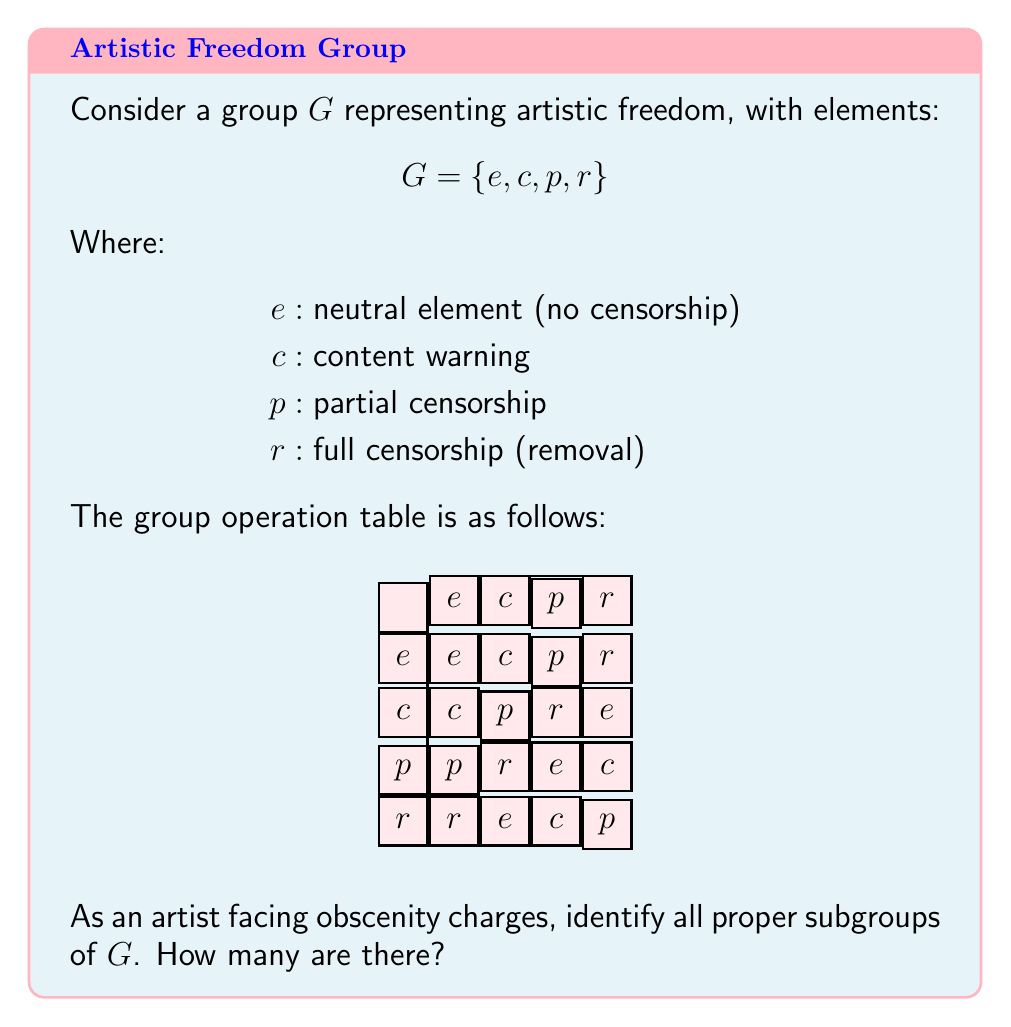Can you solve this math problem? To find the subgroups of $G$, we follow these steps:

1) First, note that $\{e\}$ is always a subgroup (the trivial subgroup).

2) Check for cyclic subgroups generated by each non-identity element:

   For $c$: $\langle c \rangle = \{e, c\}$ (order 2)
   For $p$: $\langle p \rangle = \{e, p\}$ (order 2)
   For $r$: $\langle r \rangle = \{e, r\}$ (order 2)

3) Check if there are any subgroups of order 3:
   There are no elements of order 3, so no subgroups of order 3.

4) The full group $G$ is always a subgroup of itself, but we're asked for proper subgroups.

Therefore, we have found all proper subgroups:
$\{e\}$, $\{e, c\}$, $\{e, p\}$, $\{e, r\}$

The number of proper subgroups is 4.

This group structure models artistic freedom where each subgroup represents a different level of censorship or restriction on artistic expression.
Answer: 4 proper subgroups: $\{e\}$, $\{e, c\}$, $\{e, p\}$, $\{e, r\}$ 